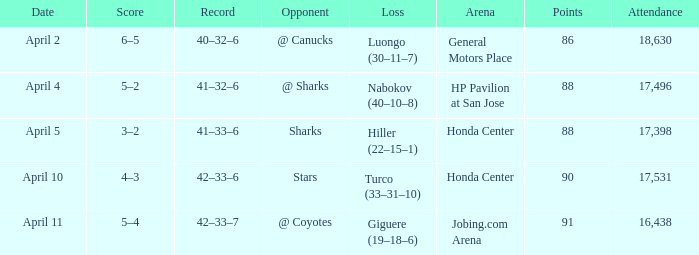Which Loss has a Record of 41–32–6? Nabokov (40–10–8). 